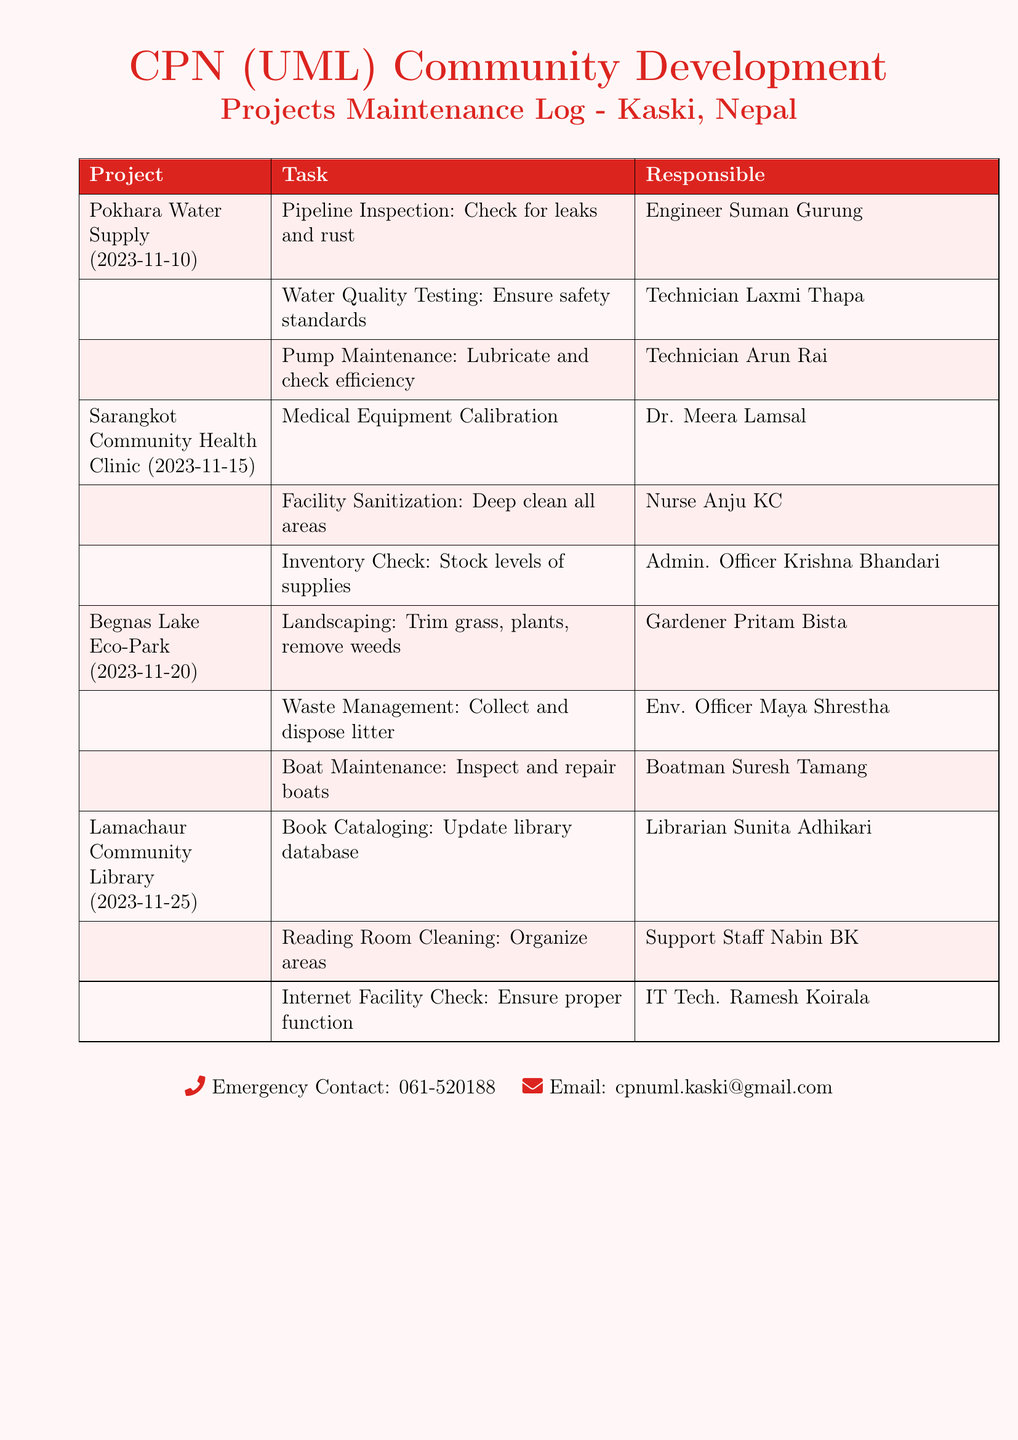What is the date for the Pokhara Water Supply project maintenance? The date for the Pokhara Water Supply project maintenance is specified as 2023-11-10.
Answer: 2023-11-10 Who is responsible for the Waste Management task in Begnas Lake Eco-Park? The Waste Management task is assigned to Env. Officer Maya Shrestha.
Answer: Maya Shrestha How many tasks are listed for the Lamachaur Community Library? The document lists three tasks for the Lamachaur Community Library.
Answer: Three What task is Dr. Meera Lamsal responsible for? Dr. Meera Lamsal is responsible for Medical Equipment Calibration.
Answer: Medical Equipment Calibration Which project has the latest date scheduled for maintenance? According to the document, the latest scheduled maintenance date is for the Lamachaur Community Library.
Answer: Lamachaur Community Library Who is responsible for Internet Facility Check? The task of Internet Facility Check is assigned to IT Tech. Ramesh Koirala.
Answer: Ramesh Koirala What is the contact email provided in the document? The document includes a contact email address for communication regarding the project.
Answer: cpnuml.kaski@gmail.com How many technicians are mentioned in the maintenance tasks? The document mentions two technicians, Laxmi Thapa and Arun Rai.
Answer: Two 